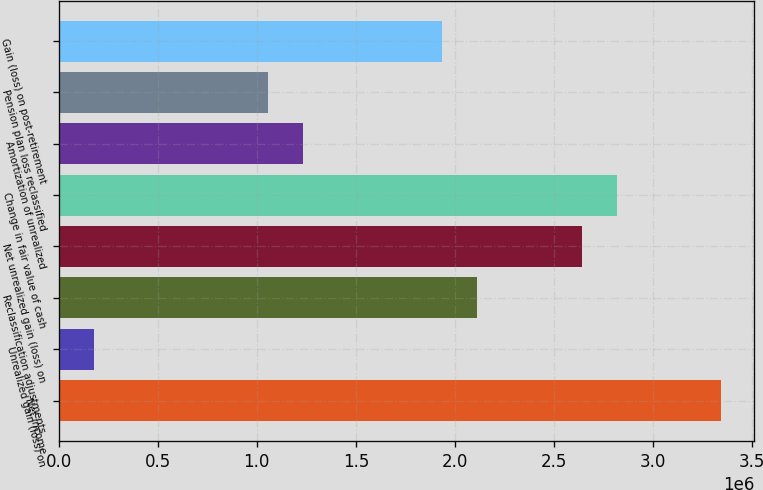Convert chart. <chart><loc_0><loc_0><loc_500><loc_500><bar_chart><fcel>Net income<fcel>Unrealized gain (loss) on<fcel>Reclassification adjustments<fcel>Net unrealized gain (loss) on<fcel>Change in fair value of cash<fcel>Amortization of unrealized<fcel>Pension plan loss reclassified<fcel>Gain (loss) on post-retirement<nl><fcel>3.34401e+06<fcel>176060<fcel>2.11203e+06<fcel>2.64002e+06<fcel>2.81602e+06<fcel>1.23204e+06<fcel>1.05604e+06<fcel>1.93603e+06<nl></chart> 